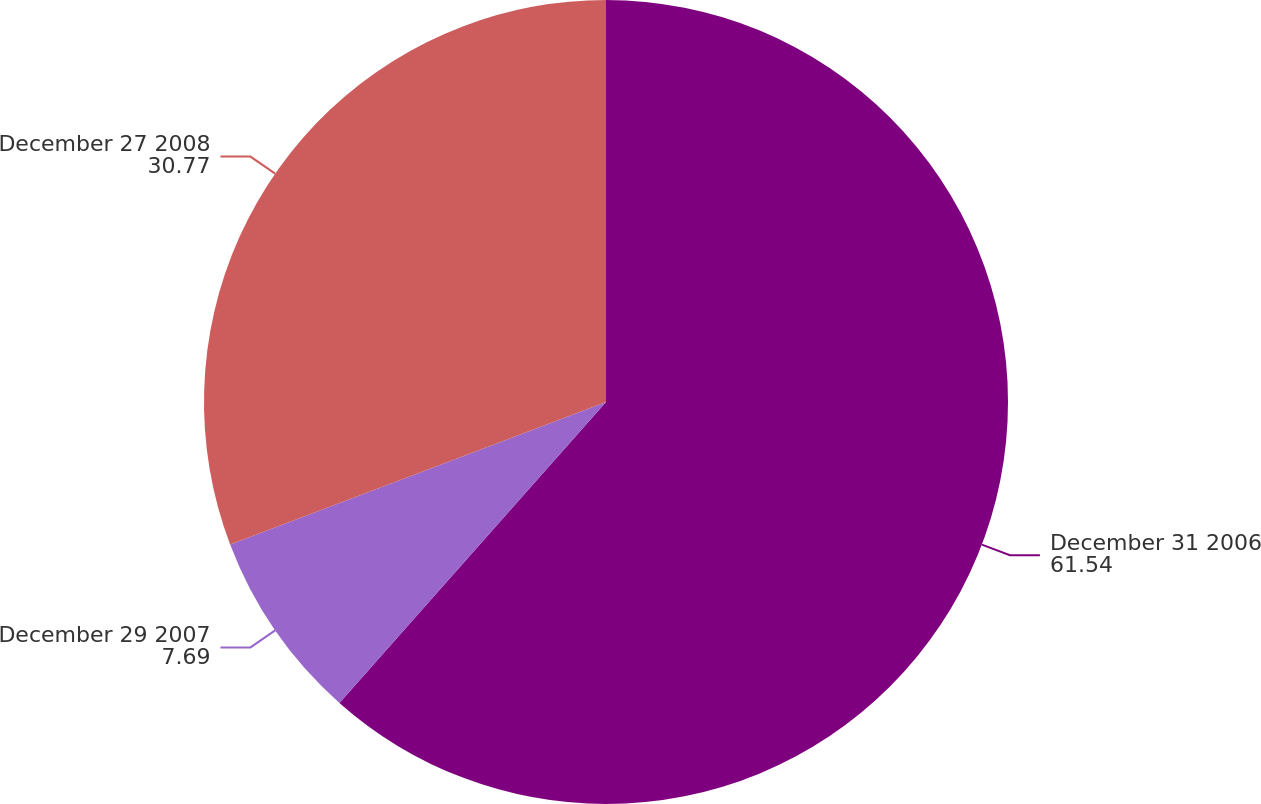Convert chart to OTSL. <chart><loc_0><loc_0><loc_500><loc_500><pie_chart><fcel>December 31 2006<fcel>December 29 2007<fcel>December 27 2008<nl><fcel>61.54%<fcel>7.69%<fcel>30.77%<nl></chart> 